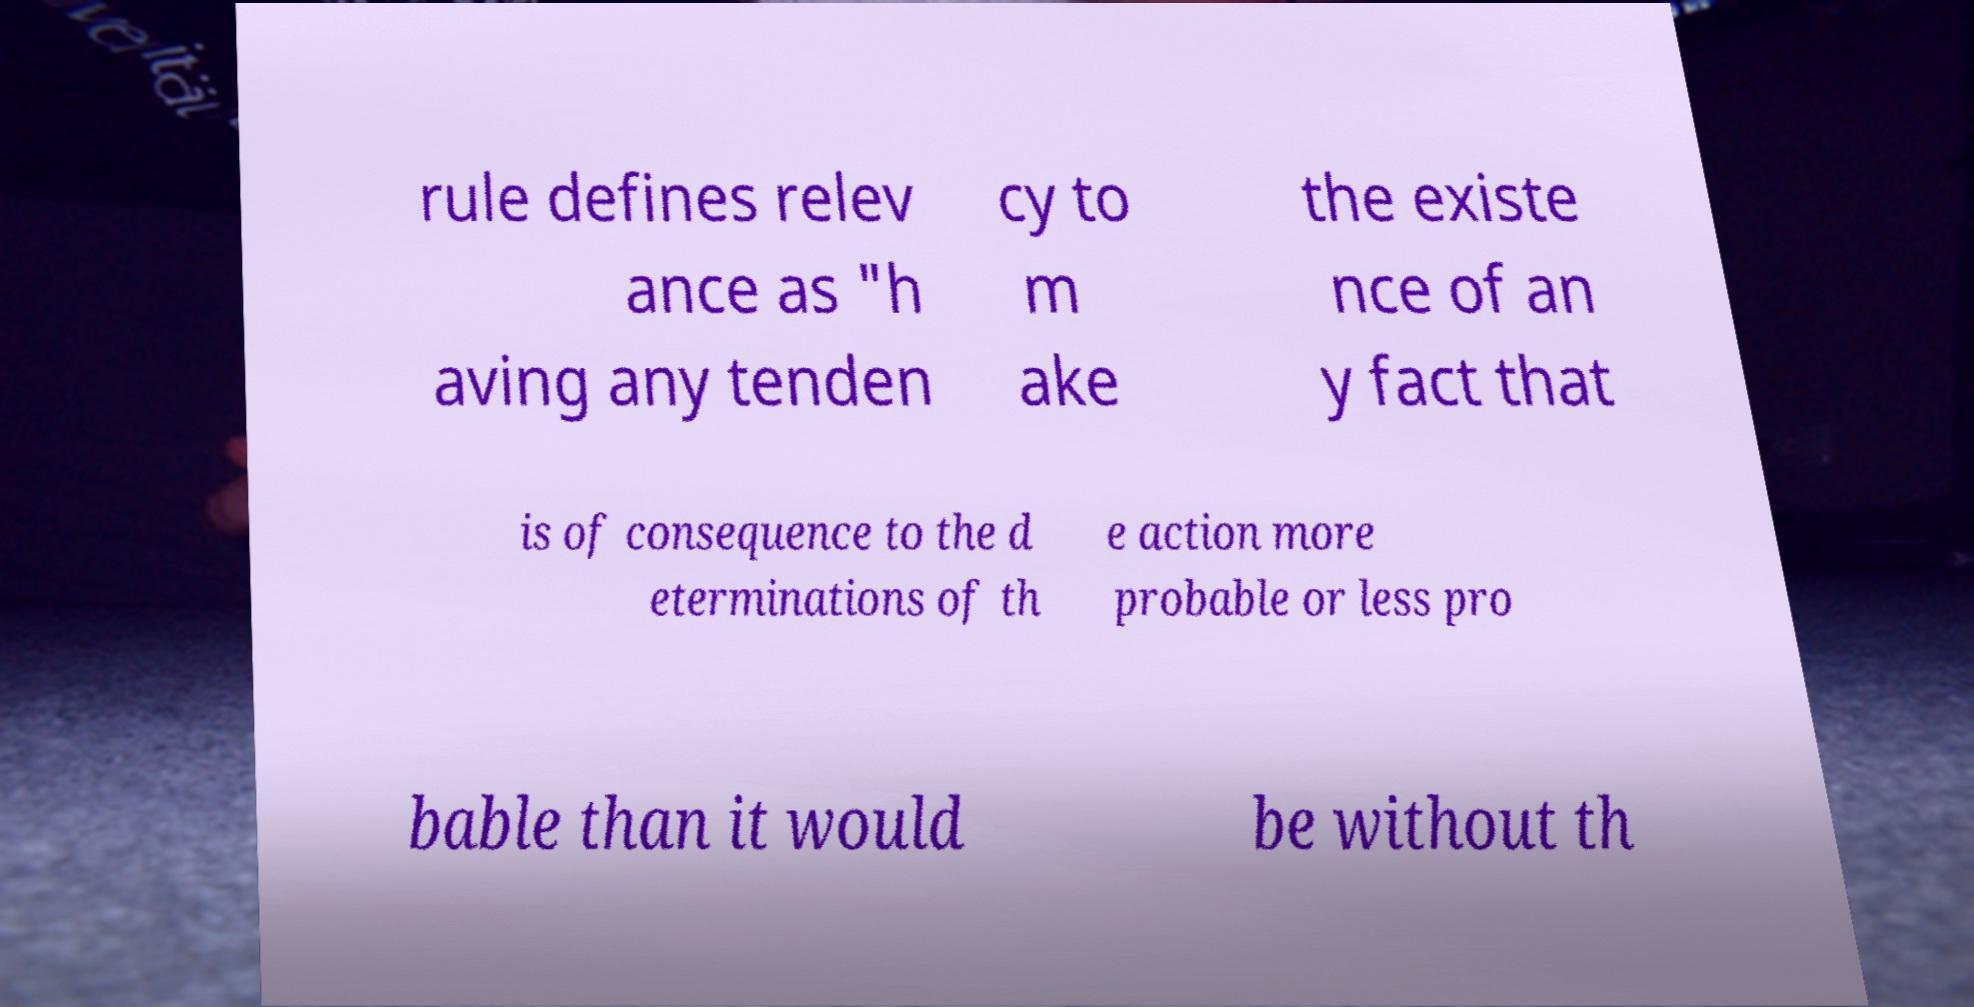Can you accurately transcribe the text from the provided image for me? rule defines relev ance as "h aving any tenden cy to m ake the existe nce of an y fact that is of consequence to the d eterminations of th e action more probable or less pro bable than it would be without th 